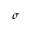Convert formula to latex. <formula><loc_0><loc_0><loc_500><loc_500>\sigma</formula> 